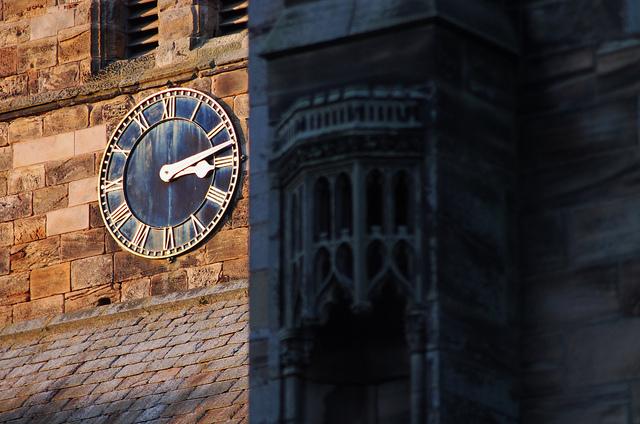What numeric characters are on the clock?
Short answer required. Roman numerals. Are the numbers on the clock Greek?
Give a very brief answer. No. What time is shown on the clock?
Quick response, please. 3:13. 